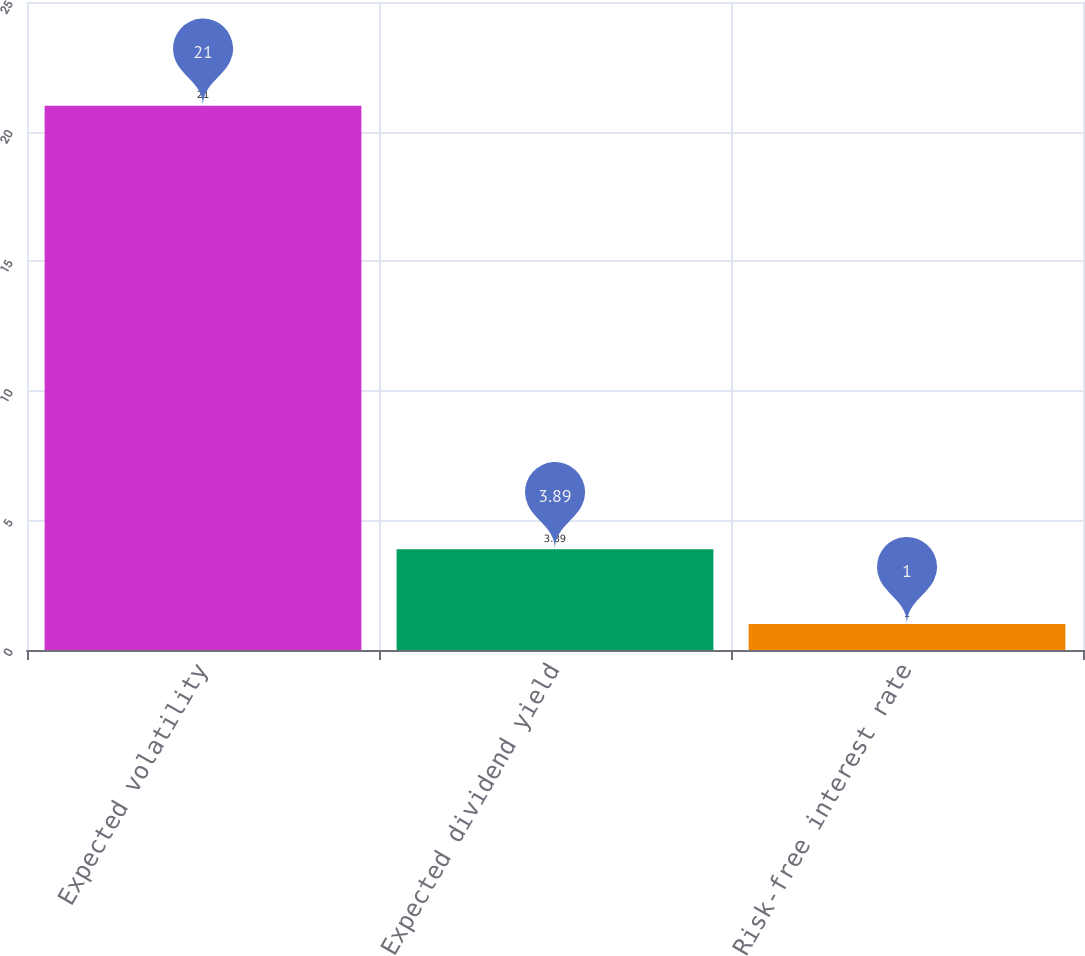Convert chart to OTSL. <chart><loc_0><loc_0><loc_500><loc_500><bar_chart><fcel>Expected volatility<fcel>Expected dividend yield<fcel>Risk-free interest rate<nl><fcel>21<fcel>3.89<fcel>1<nl></chart> 